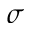Convert formula to latex. <formula><loc_0><loc_0><loc_500><loc_500>\sigma</formula> 